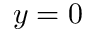<formula> <loc_0><loc_0><loc_500><loc_500>y = 0</formula> 